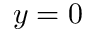<formula> <loc_0><loc_0><loc_500><loc_500>y = 0</formula> 